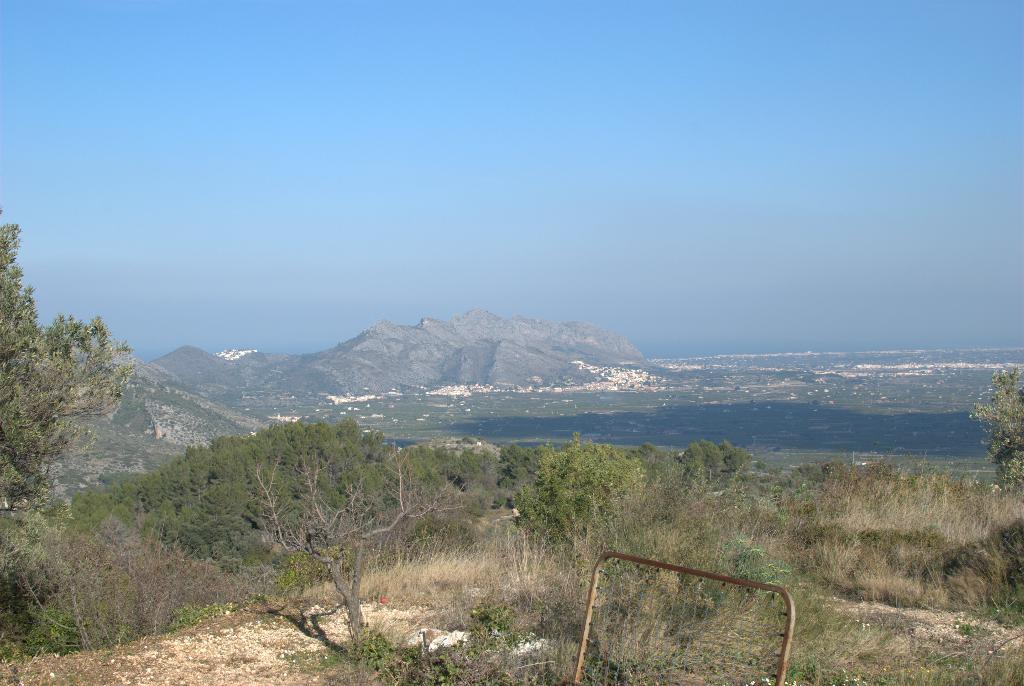What type of vegetation is present in the image? There are many trees, plants, and grass in the image. What natural features can be seen in the background of the image? There is an ocean and mountains visible in the background of the image. What part of the sky is visible in the image? The sky is visible at the top of the image. What man-made object can be seen at the bottom of the image? There is a steel pipe at the bottom of the image. What type of band is performing on the grass in the image? A: There is no band present in the image; it features trees, plants, grass, an ocean, mountains, the sky, and a steel pipe. What cast member from a popular TV show can be seen walking on the beach in the image? There are no cast members or TV shows mentioned in the image; it only features natural elements and a steel pipe. 